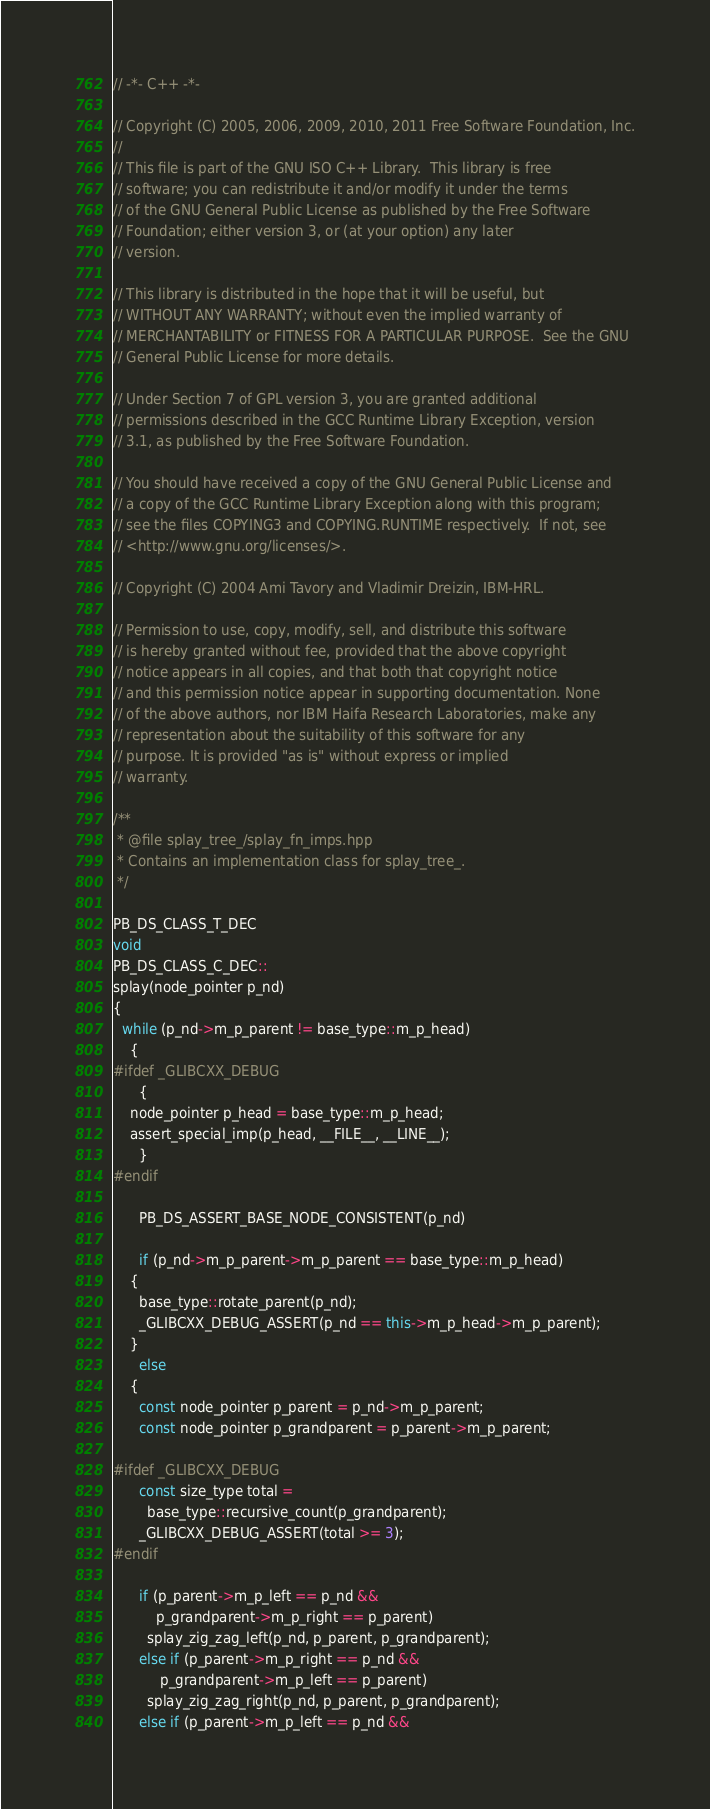Convert code to text. <code><loc_0><loc_0><loc_500><loc_500><_C++_>// -*- C++ -*-

// Copyright (C) 2005, 2006, 2009, 2010, 2011 Free Software Foundation, Inc.
//
// This file is part of the GNU ISO C++ Library.  This library is free
// software; you can redistribute it and/or modify it under the terms
// of the GNU General Public License as published by the Free Software
// Foundation; either version 3, or (at your option) any later
// version.

// This library is distributed in the hope that it will be useful, but
// WITHOUT ANY WARRANTY; without even the implied warranty of
// MERCHANTABILITY or FITNESS FOR A PARTICULAR PURPOSE.  See the GNU
// General Public License for more details.

// Under Section 7 of GPL version 3, you are granted additional
// permissions described in the GCC Runtime Library Exception, version
// 3.1, as published by the Free Software Foundation.

// You should have received a copy of the GNU General Public License and
// a copy of the GCC Runtime Library Exception along with this program;
// see the files COPYING3 and COPYING.RUNTIME respectively.  If not, see
// <http://www.gnu.org/licenses/>.

// Copyright (C) 2004 Ami Tavory and Vladimir Dreizin, IBM-HRL.

// Permission to use, copy, modify, sell, and distribute this software
// is hereby granted without fee, provided that the above copyright
// notice appears in all copies, and that both that copyright notice
// and this permission notice appear in supporting documentation. None
// of the above authors, nor IBM Haifa Research Laboratories, make any
// representation about the suitability of this software for any
// purpose. It is provided "as is" without express or implied
// warranty.

/**
 * @file splay_tree_/splay_fn_imps.hpp
 * Contains an implementation class for splay_tree_.
 */

PB_DS_CLASS_T_DEC
void
PB_DS_CLASS_C_DEC::
splay(node_pointer p_nd)
{
  while (p_nd->m_p_parent != base_type::m_p_head)
    {
#ifdef _GLIBCXX_DEBUG
      {
	node_pointer p_head = base_type::m_p_head;
	assert_special_imp(p_head, __FILE__, __LINE__);
      }
#endif

      PB_DS_ASSERT_BASE_NODE_CONSISTENT(p_nd)

      if (p_nd->m_p_parent->m_p_parent == base_type::m_p_head)
	{
	  base_type::rotate_parent(p_nd);
	  _GLIBCXX_DEBUG_ASSERT(p_nd == this->m_p_head->m_p_parent);
	}
      else
	{
	  const node_pointer p_parent = p_nd->m_p_parent;
	  const node_pointer p_grandparent = p_parent->m_p_parent;

#ifdef _GLIBCXX_DEBUG
	  const size_type total =
	    base_type::recursive_count(p_grandparent);
	  _GLIBCXX_DEBUG_ASSERT(total >= 3);
#endif

	  if (p_parent->m_p_left == p_nd &&
	      p_grandparent->m_p_right == p_parent)
	    splay_zig_zag_left(p_nd, p_parent, p_grandparent);
	  else if (p_parent->m_p_right == p_nd &&
		   p_grandparent->m_p_left == p_parent)
	    splay_zig_zag_right(p_nd, p_parent, p_grandparent);
	  else if (p_parent->m_p_left == p_nd &&</code> 